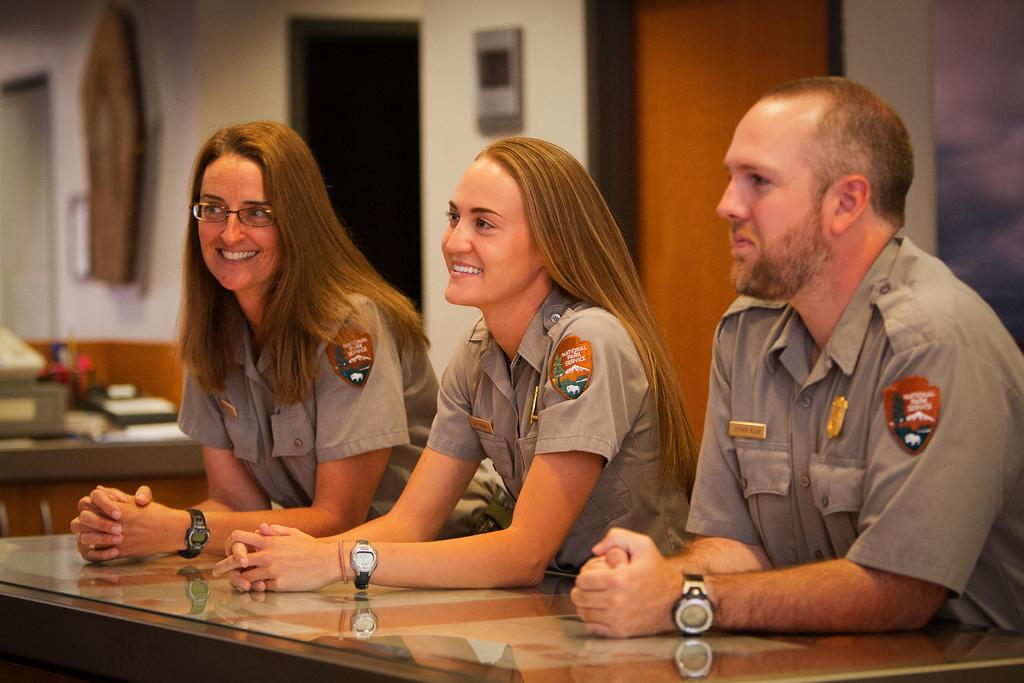How many people are in the foreground of the picture? There are three people in the foreground of the picture: two women and a man. What is located in the foreground of the picture with the people? There is a table in the foreground of the picture. Can you describe the background of the image? The background of the image is blurred, and there is a wall, a frame, and another table present. What other objects can be seen in the background of the image? Various objects are present in the background of the image. What type of gun is being fired in the image? There is no gun present in the image; it features three people and various objects in the background. Can you describe the smell of the hen in the image? There is no hen present in the image, so it is not possible to describe its smell. 